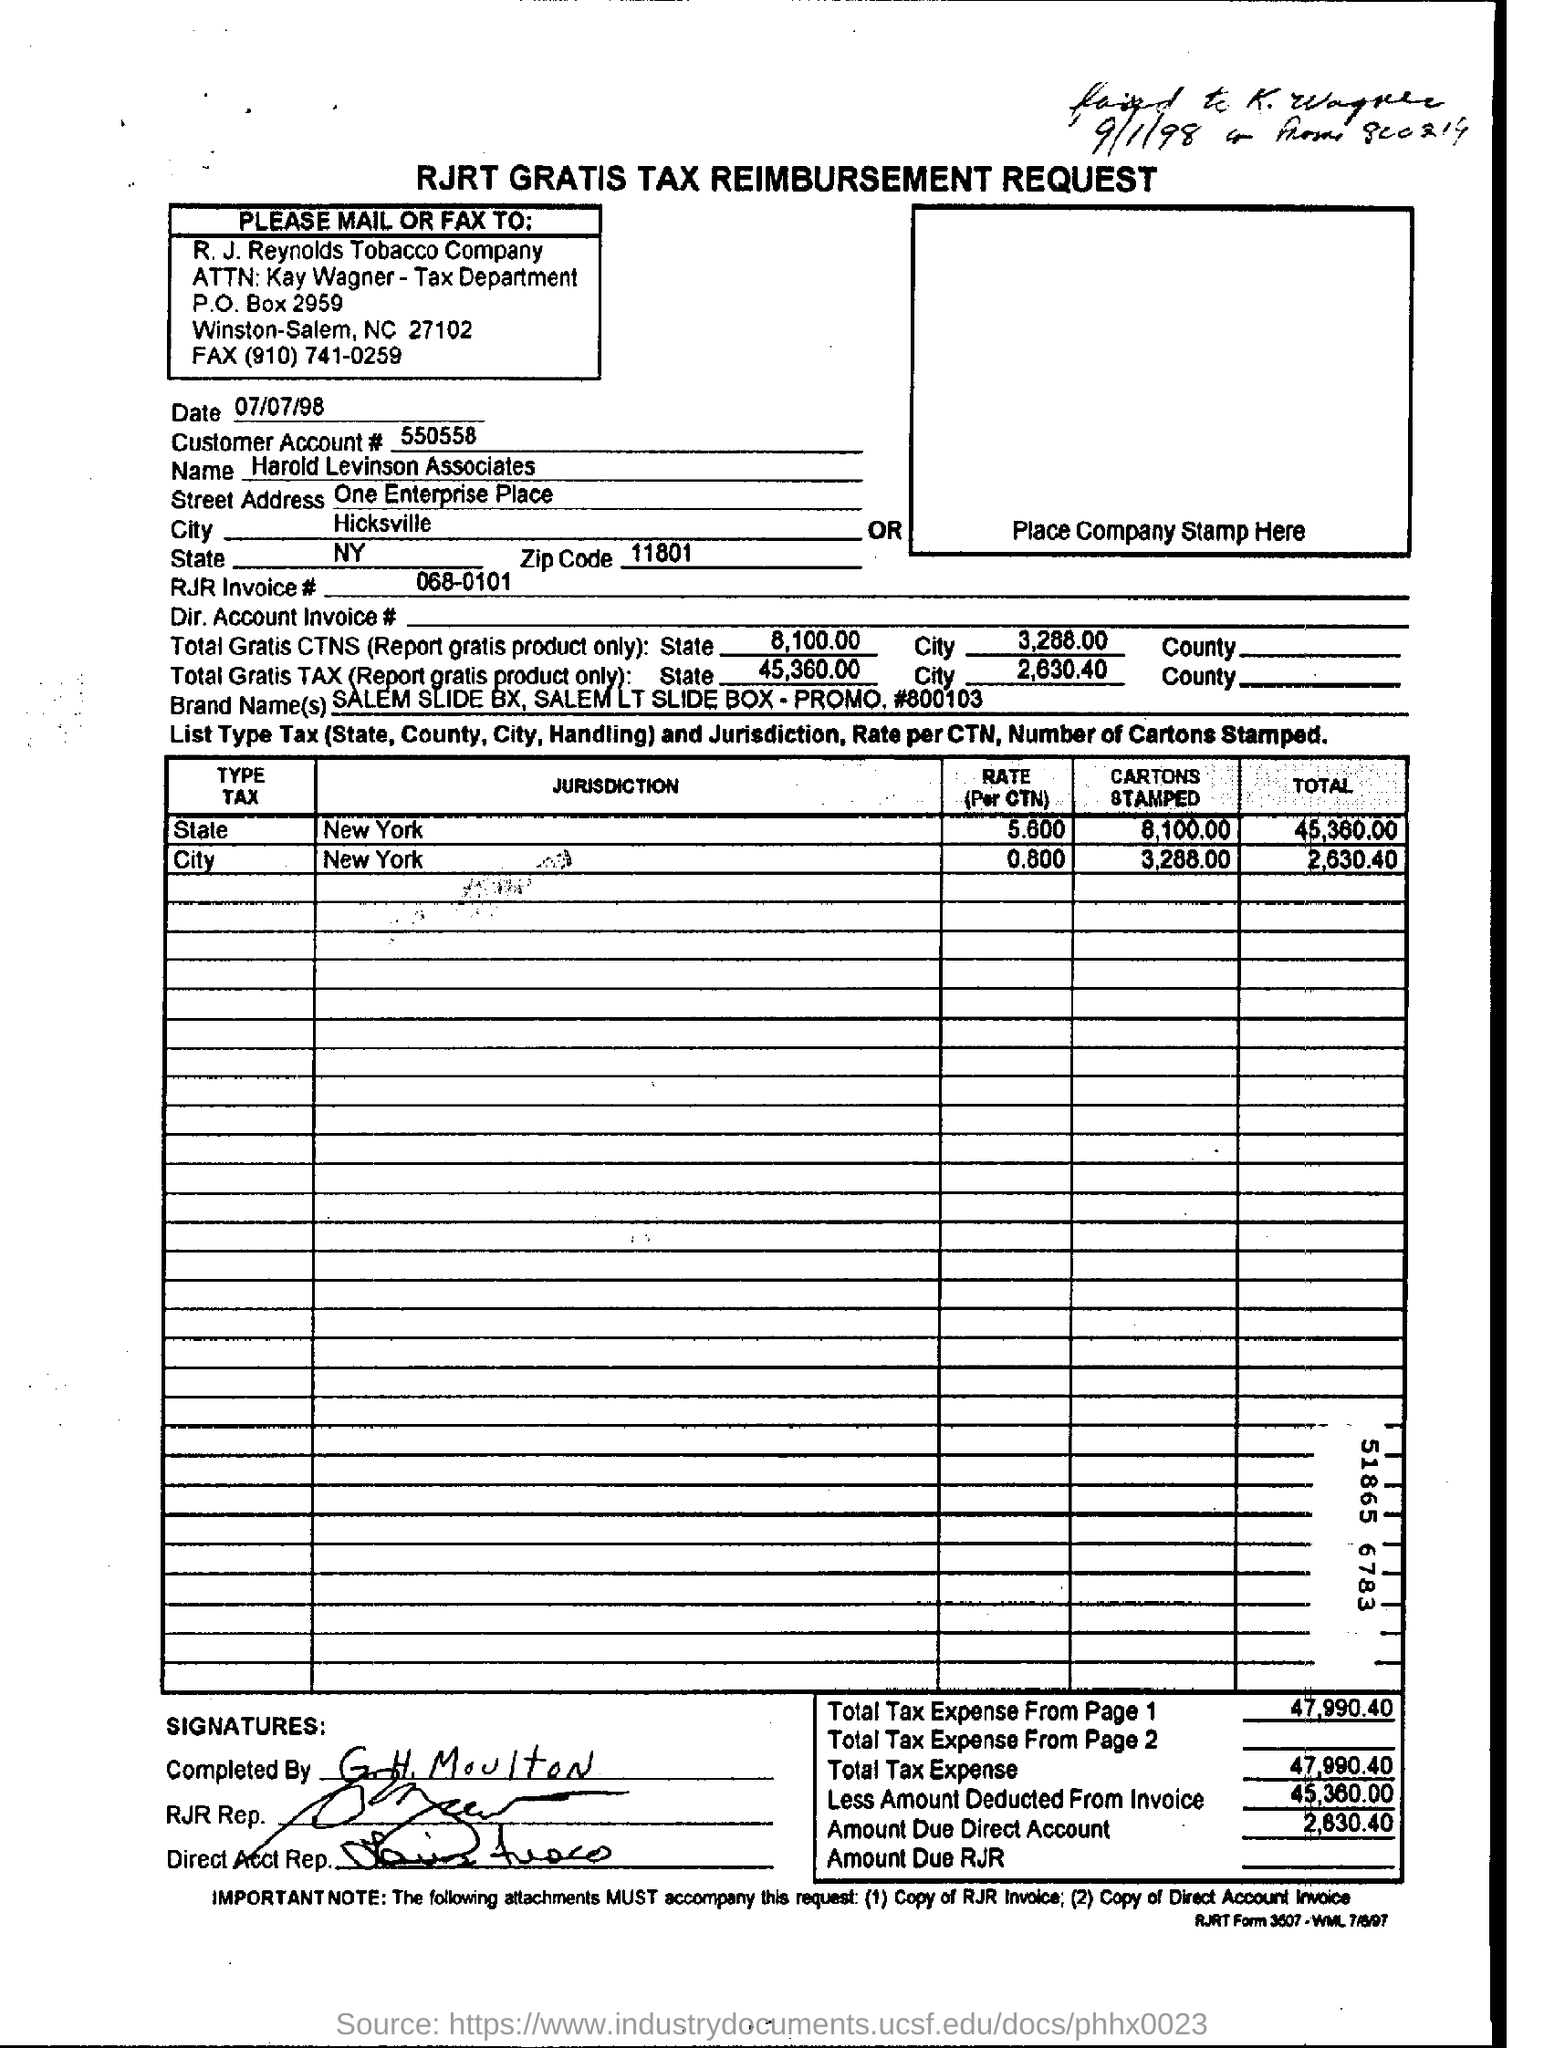What is the customer account nymber?
Offer a very short reply. 550558. 